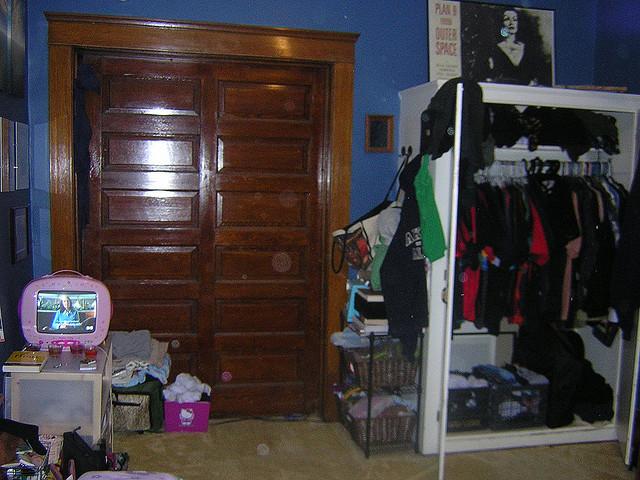Is this a bathroom?
Give a very brief answer. No. What can you see the sun reflecting on?
Keep it brief. Door. Is hello kitty in this scene?
Keep it brief. Yes. What color is the wall?
Be succinct. Blue. What color are the walls?
Keep it brief. Blue. How many shoes are on the shelf?
Short answer required. 0. Where is this?
Concise answer only. Bedroom. Is this a child's room?
Answer briefly. Yes. What is the color of the wall?
Short answer required. Blue. What kind of room did these things probably come out of?
Be succinct. Bedroom. Is this indoors?
Give a very brief answer. Yes. Is this a kitchen?
Answer briefly. No. What room is this?
Write a very short answer. Bedroom. What is inside?
Give a very brief answer. Clothes. Is there any vegetation?
Be succinct. No. How many teddy bears are there?
Give a very brief answer. 0. Where are the teddy bears?
Be succinct. Closet. 